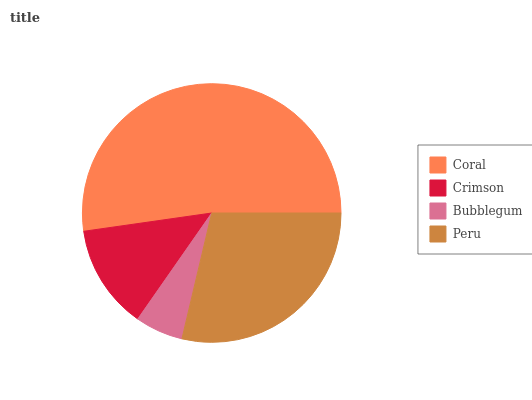Is Bubblegum the minimum?
Answer yes or no. Yes. Is Coral the maximum?
Answer yes or no. Yes. Is Crimson the minimum?
Answer yes or no. No. Is Crimson the maximum?
Answer yes or no. No. Is Coral greater than Crimson?
Answer yes or no. Yes. Is Crimson less than Coral?
Answer yes or no. Yes. Is Crimson greater than Coral?
Answer yes or no. No. Is Coral less than Crimson?
Answer yes or no. No. Is Peru the high median?
Answer yes or no. Yes. Is Crimson the low median?
Answer yes or no. Yes. Is Crimson the high median?
Answer yes or no. No. Is Bubblegum the low median?
Answer yes or no. No. 